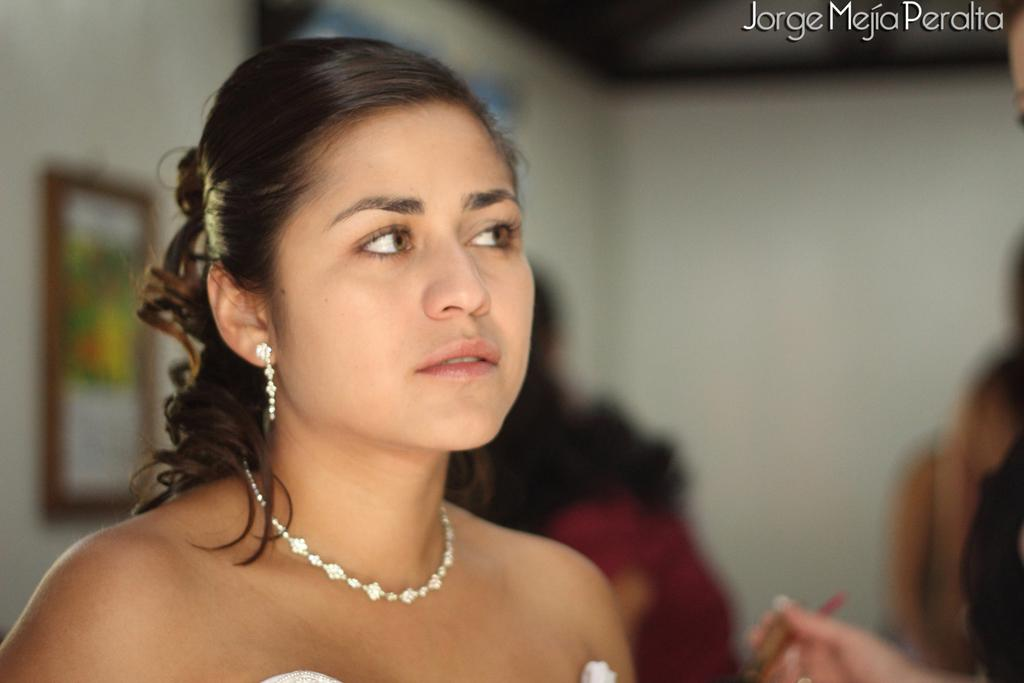Who is the main subject in the image? There is a woman in the picture. What is the woman wearing in the image? The woman is wearing a necklace. Can you describe the background of the image? The background of the image is blurred. Where is the text located in the image? The text is in the top right side of the image. How many horses are depicted in the image? There are no horses present in the image. What is the plot of the story being told in the image? The image does not depict a story or plot; it is a picture of a woman wearing a necklace. 